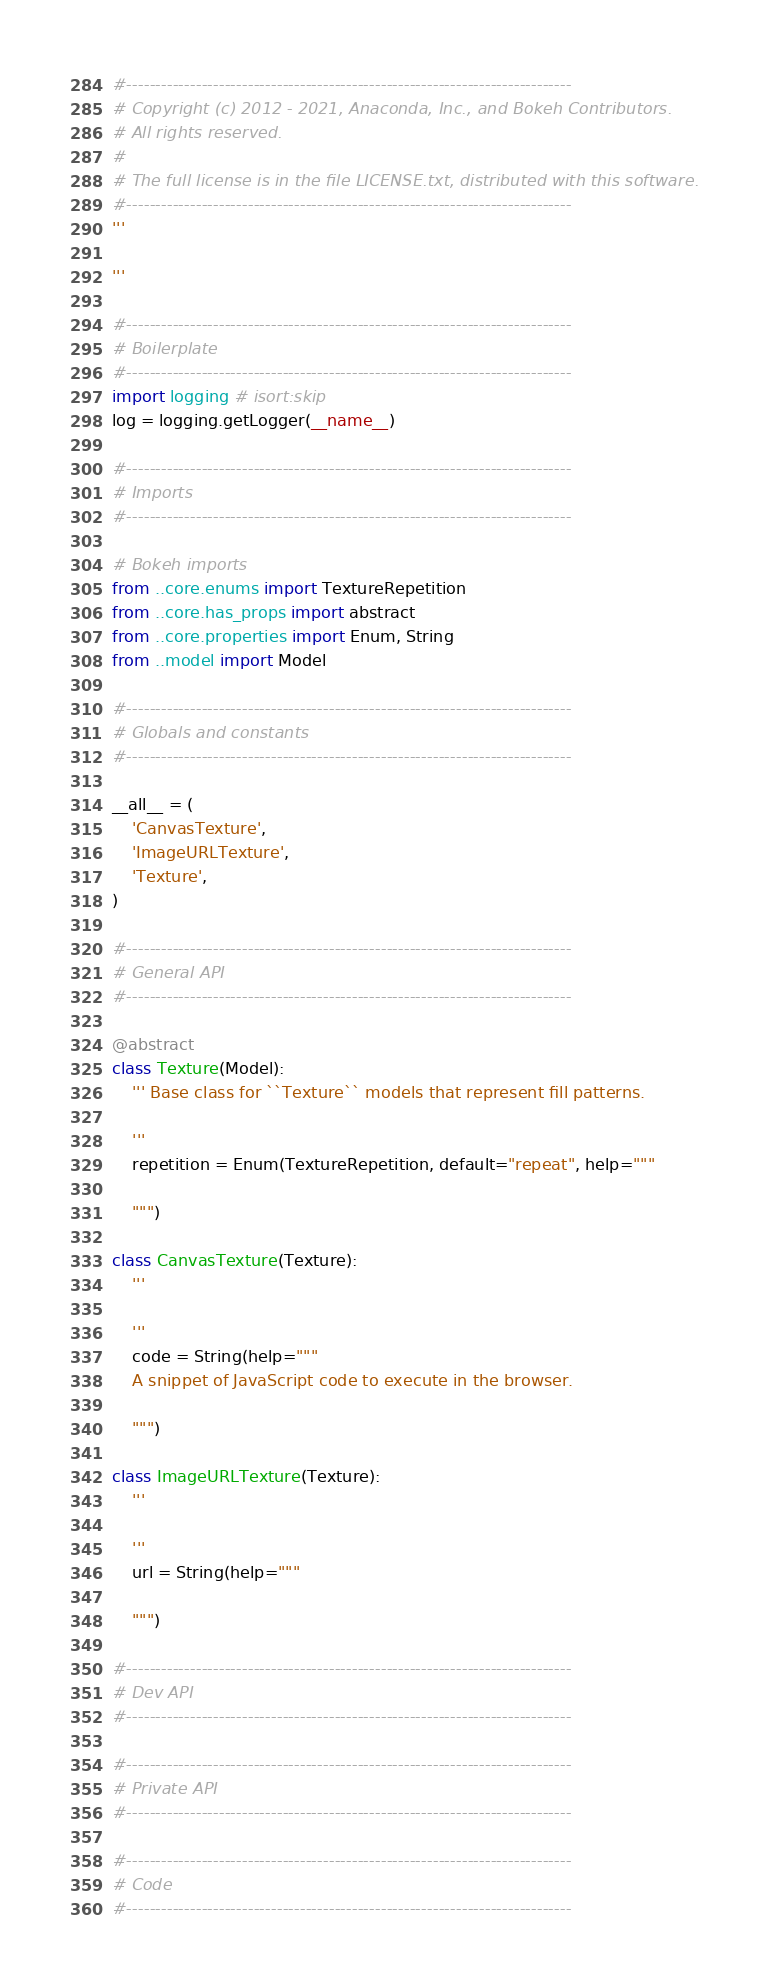<code> <loc_0><loc_0><loc_500><loc_500><_Python_>#-----------------------------------------------------------------------------
# Copyright (c) 2012 - 2021, Anaconda, Inc., and Bokeh Contributors.
# All rights reserved.
#
# The full license is in the file LICENSE.txt, distributed with this software.
#-----------------------------------------------------------------------------
'''

'''

#-----------------------------------------------------------------------------
# Boilerplate
#-----------------------------------------------------------------------------
import logging # isort:skip
log = logging.getLogger(__name__)

#-----------------------------------------------------------------------------
# Imports
#-----------------------------------------------------------------------------

# Bokeh imports
from ..core.enums import TextureRepetition
from ..core.has_props import abstract
from ..core.properties import Enum, String
from ..model import Model

#-----------------------------------------------------------------------------
# Globals and constants
#-----------------------------------------------------------------------------

__all__ = (
    'CanvasTexture',
    'ImageURLTexture',
    'Texture',
)

#-----------------------------------------------------------------------------
# General API
#-----------------------------------------------------------------------------

@abstract
class Texture(Model):
    ''' Base class for ``Texture`` models that represent fill patterns.

    '''
    repetition = Enum(TextureRepetition, default="repeat", help="""

    """)

class CanvasTexture(Texture):
    '''

    '''
    code = String(help="""
    A snippet of JavaScript code to execute in the browser.

    """)

class ImageURLTexture(Texture):
    '''

    '''
    url = String(help="""

    """)

#-----------------------------------------------------------------------------
# Dev API
#-----------------------------------------------------------------------------

#-----------------------------------------------------------------------------
# Private API
#-----------------------------------------------------------------------------

#-----------------------------------------------------------------------------
# Code
#-----------------------------------------------------------------------------
</code> 